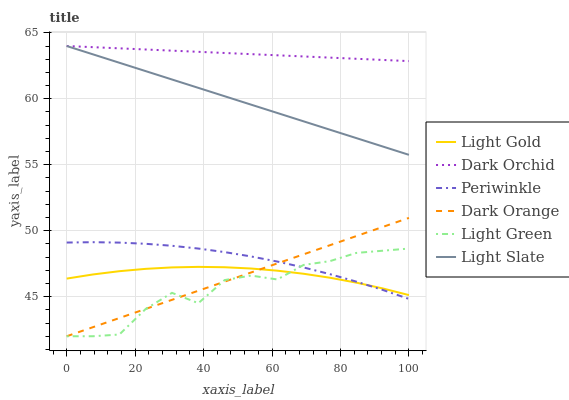Does Light Green have the minimum area under the curve?
Answer yes or no. Yes. Does Dark Orchid have the maximum area under the curve?
Answer yes or no. Yes. Does Light Slate have the minimum area under the curve?
Answer yes or no. No. Does Light Slate have the maximum area under the curve?
Answer yes or no. No. Is Light Slate the smoothest?
Answer yes or no. Yes. Is Light Green the roughest?
Answer yes or no. Yes. Is Dark Orchid the smoothest?
Answer yes or no. No. Is Dark Orchid the roughest?
Answer yes or no. No. Does Dark Orange have the lowest value?
Answer yes or no. Yes. Does Light Slate have the lowest value?
Answer yes or no. No. Does Dark Orchid have the highest value?
Answer yes or no. Yes. Does Periwinkle have the highest value?
Answer yes or no. No. Is Light Green less than Dark Orchid?
Answer yes or no. Yes. Is Dark Orchid greater than Light Green?
Answer yes or no. Yes. Does Light Green intersect Dark Orange?
Answer yes or no. Yes. Is Light Green less than Dark Orange?
Answer yes or no. No. Is Light Green greater than Dark Orange?
Answer yes or no. No. Does Light Green intersect Dark Orchid?
Answer yes or no. No. 